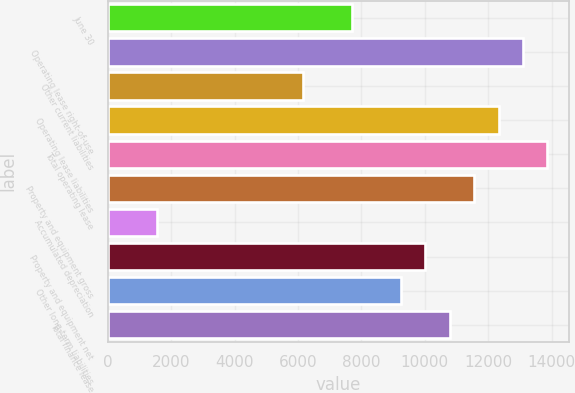<chart> <loc_0><loc_0><loc_500><loc_500><bar_chart><fcel>June 30<fcel>Operating lease right-of-use<fcel>Other current liabilities<fcel>Operating lease liabilities<fcel>Total operating lease<fcel>Property and equipment gross<fcel>Accumulated depreciation<fcel>Property and equipment net<fcel>Other long-term liabilities<fcel>Total finance lease<nl><fcel>7705<fcel>13096.6<fcel>6164.54<fcel>12326.4<fcel>13866.8<fcel>11556.1<fcel>1543.16<fcel>10015.7<fcel>9245.46<fcel>10785.9<nl></chart> 